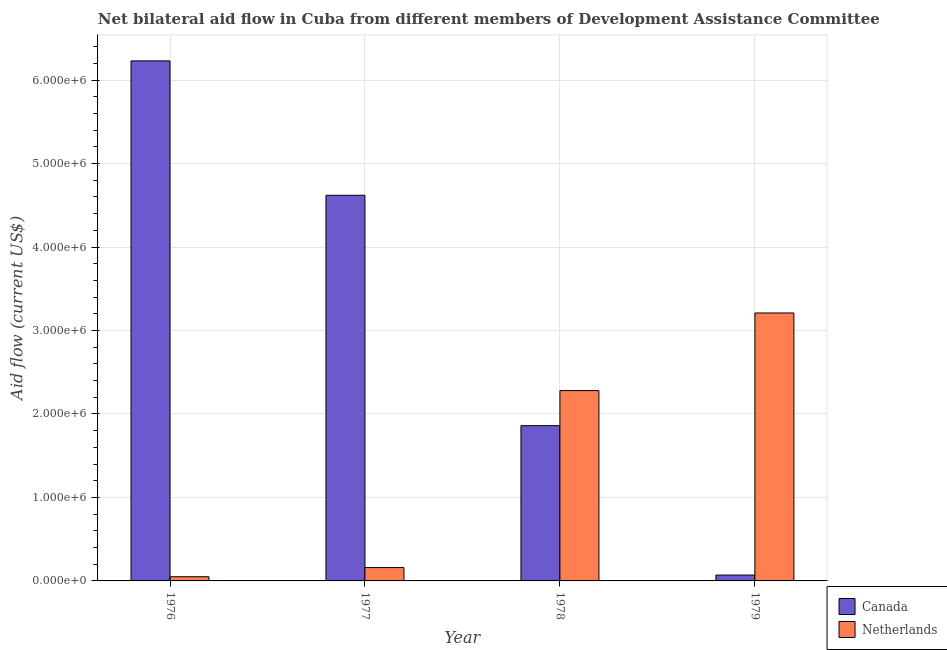How many different coloured bars are there?
Offer a terse response. 2. Are the number of bars on each tick of the X-axis equal?
Your response must be concise. Yes. How many bars are there on the 1st tick from the left?
Ensure brevity in your answer.  2. What is the label of the 3rd group of bars from the left?
Your answer should be very brief. 1978. What is the amount of aid given by canada in 1978?
Provide a succinct answer. 1.86e+06. Across all years, what is the maximum amount of aid given by canada?
Give a very brief answer. 6.23e+06. Across all years, what is the minimum amount of aid given by canada?
Offer a very short reply. 7.00e+04. In which year was the amount of aid given by canada maximum?
Your answer should be compact. 1976. In which year was the amount of aid given by netherlands minimum?
Give a very brief answer. 1976. What is the total amount of aid given by canada in the graph?
Your response must be concise. 1.28e+07. What is the difference between the amount of aid given by canada in 1976 and that in 1979?
Provide a succinct answer. 6.16e+06. What is the difference between the amount of aid given by canada in 1978 and the amount of aid given by netherlands in 1976?
Provide a succinct answer. -4.37e+06. What is the average amount of aid given by canada per year?
Give a very brief answer. 3.20e+06. In how many years, is the amount of aid given by netherlands greater than 6000000 US$?
Provide a short and direct response. 0. What is the ratio of the amount of aid given by canada in 1977 to that in 1978?
Provide a short and direct response. 2.48. Is the amount of aid given by netherlands in 1977 less than that in 1979?
Offer a terse response. Yes. What is the difference between the highest and the second highest amount of aid given by canada?
Offer a very short reply. 1.61e+06. What is the difference between the highest and the lowest amount of aid given by canada?
Keep it short and to the point. 6.16e+06. How many bars are there?
Provide a short and direct response. 8. How many years are there in the graph?
Offer a terse response. 4. Where does the legend appear in the graph?
Your response must be concise. Bottom right. How many legend labels are there?
Your response must be concise. 2. How are the legend labels stacked?
Your answer should be compact. Vertical. What is the title of the graph?
Provide a succinct answer. Net bilateral aid flow in Cuba from different members of Development Assistance Committee. Does "International Tourists" appear as one of the legend labels in the graph?
Offer a very short reply. No. What is the label or title of the X-axis?
Make the answer very short. Year. What is the Aid flow (current US$) of Canada in 1976?
Make the answer very short. 6.23e+06. What is the Aid flow (current US$) of Netherlands in 1976?
Provide a succinct answer. 5.00e+04. What is the Aid flow (current US$) of Canada in 1977?
Your response must be concise. 4.62e+06. What is the Aid flow (current US$) of Canada in 1978?
Offer a terse response. 1.86e+06. What is the Aid flow (current US$) in Netherlands in 1978?
Ensure brevity in your answer.  2.28e+06. What is the Aid flow (current US$) in Netherlands in 1979?
Provide a short and direct response. 3.21e+06. Across all years, what is the maximum Aid flow (current US$) of Canada?
Make the answer very short. 6.23e+06. Across all years, what is the maximum Aid flow (current US$) of Netherlands?
Keep it short and to the point. 3.21e+06. Across all years, what is the minimum Aid flow (current US$) of Canada?
Ensure brevity in your answer.  7.00e+04. Across all years, what is the minimum Aid flow (current US$) in Netherlands?
Your answer should be very brief. 5.00e+04. What is the total Aid flow (current US$) in Canada in the graph?
Keep it short and to the point. 1.28e+07. What is the total Aid flow (current US$) of Netherlands in the graph?
Your answer should be compact. 5.70e+06. What is the difference between the Aid flow (current US$) of Canada in 1976 and that in 1977?
Provide a succinct answer. 1.61e+06. What is the difference between the Aid flow (current US$) in Netherlands in 1976 and that in 1977?
Keep it short and to the point. -1.10e+05. What is the difference between the Aid flow (current US$) of Canada in 1976 and that in 1978?
Your answer should be very brief. 4.37e+06. What is the difference between the Aid flow (current US$) of Netherlands in 1976 and that in 1978?
Offer a terse response. -2.23e+06. What is the difference between the Aid flow (current US$) of Canada in 1976 and that in 1979?
Offer a very short reply. 6.16e+06. What is the difference between the Aid flow (current US$) of Netherlands in 1976 and that in 1979?
Your answer should be compact. -3.16e+06. What is the difference between the Aid flow (current US$) in Canada in 1977 and that in 1978?
Provide a succinct answer. 2.76e+06. What is the difference between the Aid flow (current US$) in Netherlands in 1977 and that in 1978?
Keep it short and to the point. -2.12e+06. What is the difference between the Aid flow (current US$) in Canada in 1977 and that in 1979?
Offer a terse response. 4.55e+06. What is the difference between the Aid flow (current US$) in Netherlands in 1977 and that in 1979?
Make the answer very short. -3.05e+06. What is the difference between the Aid flow (current US$) of Canada in 1978 and that in 1979?
Offer a very short reply. 1.79e+06. What is the difference between the Aid flow (current US$) in Netherlands in 1978 and that in 1979?
Your answer should be very brief. -9.30e+05. What is the difference between the Aid flow (current US$) in Canada in 1976 and the Aid flow (current US$) in Netherlands in 1977?
Give a very brief answer. 6.07e+06. What is the difference between the Aid flow (current US$) of Canada in 1976 and the Aid flow (current US$) of Netherlands in 1978?
Offer a very short reply. 3.95e+06. What is the difference between the Aid flow (current US$) of Canada in 1976 and the Aid flow (current US$) of Netherlands in 1979?
Your response must be concise. 3.02e+06. What is the difference between the Aid flow (current US$) in Canada in 1977 and the Aid flow (current US$) in Netherlands in 1978?
Make the answer very short. 2.34e+06. What is the difference between the Aid flow (current US$) in Canada in 1977 and the Aid flow (current US$) in Netherlands in 1979?
Your answer should be very brief. 1.41e+06. What is the difference between the Aid flow (current US$) of Canada in 1978 and the Aid flow (current US$) of Netherlands in 1979?
Your response must be concise. -1.35e+06. What is the average Aid flow (current US$) in Canada per year?
Offer a terse response. 3.20e+06. What is the average Aid flow (current US$) of Netherlands per year?
Make the answer very short. 1.42e+06. In the year 1976, what is the difference between the Aid flow (current US$) in Canada and Aid flow (current US$) in Netherlands?
Offer a terse response. 6.18e+06. In the year 1977, what is the difference between the Aid flow (current US$) in Canada and Aid flow (current US$) in Netherlands?
Provide a succinct answer. 4.46e+06. In the year 1978, what is the difference between the Aid flow (current US$) in Canada and Aid flow (current US$) in Netherlands?
Your answer should be compact. -4.20e+05. In the year 1979, what is the difference between the Aid flow (current US$) in Canada and Aid flow (current US$) in Netherlands?
Your response must be concise. -3.14e+06. What is the ratio of the Aid flow (current US$) of Canada in 1976 to that in 1977?
Your answer should be compact. 1.35. What is the ratio of the Aid flow (current US$) of Netherlands in 1976 to that in 1977?
Provide a short and direct response. 0.31. What is the ratio of the Aid flow (current US$) of Canada in 1976 to that in 1978?
Your answer should be compact. 3.35. What is the ratio of the Aid flow (current US$) of Netherlands in 1976 to that in 1978?
Your response must be concise. 0.02. What is the ratio of the Aid flow (current US$) of Canada in 1976 to that in 1979?
Provide a short and direct response. 89. What is the ratio of the Aid flow (current US$) of Netherlands in 1976 to that in 1979?
Your response must be concise. 0.02. What is the ratio of the Aid flow (current US$) in Canada in 1977 to that in 1978?
Keep it short and to the point. 2.48. What is the ratio of the Aid flow (current US$) of Netherlands in 1977 to that in 1978?
Your answer should be compact. 0.07. What is the ratio of the Aid flow (current US$) in Netherlands in 1977 to that in 1979?
Make the answer very short. 0.05. What is the ratio of the Aid flow (current US$) in Canada in 1978 to that in 1979?
Your answer should be compact. 26.57. What is the ratio of the Aid flow (current US$) in Netherlands in 1978 to that in 1979?
Offer a terse response. 0.71. What is the difference between the highest and the second highest Aid flow (current US$) in Canada?
Offer a terse response. 1.61e+06. What is the difference between the highest and the second highest Aid flow (current US$) of Netherlands?
Provide a succinct answer. 9.30e+05. What is the difference between the highest and the lowest Aid flow (current US$) of Canada?
Ensure brevity in your answer.  6.16e+06. What is the difference between the highest and the lowest Aid flow (current US$) of Netherlands?
Make the answer very short. 3.16e+06. 